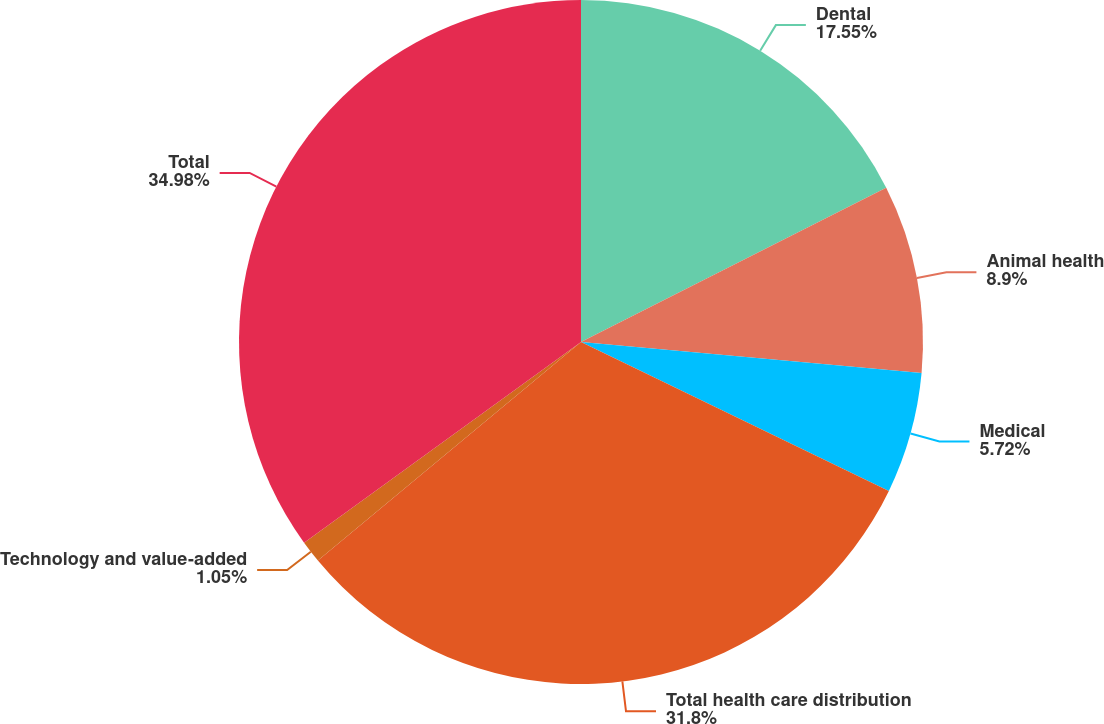<chart> <loc_0><loc_0><loc_500><loc_500><pie_chart><fcel>Dental<fcel>Animal health<fcel>Medical<fcel>Total health care distribution<fcel>Technology and value-added<fcel>Total<nl><fcel>17.55%<fcel>8.9%<fcel>5.72%<fcel>31.8%<fcel>1.05%<fcel>34.98%<nl></chart> 